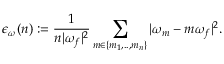<formula> <loc_0><loc_0><loc_500><loc_500>\epsilon _ { \omega } ( n ) \colon = \frac { 1 } { n | \omega _ { f } | ^ { 2 } } \sum _ { m \in \{ m _ { 1 } , . . , m _ { n } \} } | \omega _ { m } - m \omega _ { f } | ^ { 2 } .</formula> 